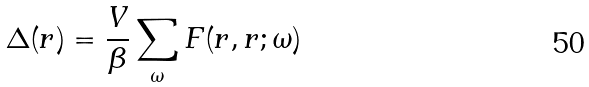Convert formula to latex. <formula><loc_0><loc_0><loc_500><loc_500>\Delta ( { r } ) = \frac { V } { \beta } \sum _ { \omega } F ( { r } , { r } ; \omega )</formula> 